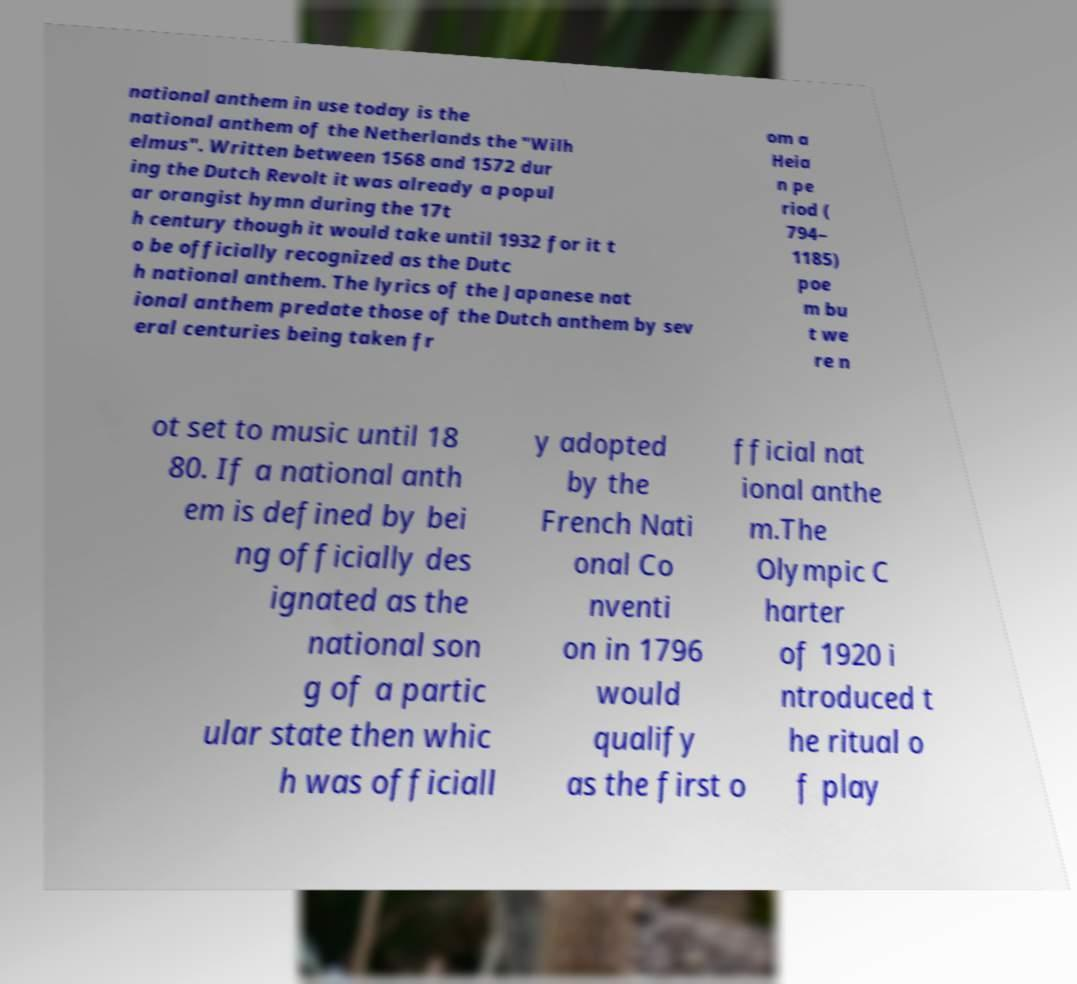What messages or text are displayed in this image? I need them in a readable, typed format. national anthem in use today is the national anthem of the Netherlands the "Wilh elmus". Written between 1568 and 1572 dur ing the Dutch Revolt it was already a popul ar orangist hymn during the 17t h century though it would take until 1932 for it t o be officially recognized as the Dutc h national anthem. The lyrics of the Japanese nat ional anthem predate those of the Dutch anthem by sev eral centuries being taken fr om a Heia n pe riod ( 794– 1185) poe m bu t we re n ot set to music until 18 80. If a national anth em is defined by bei ng officially des ignated as the national son g of a partic ular state then whic h was officiall y adopted by the French Nati onal Co nventi on in 1796 would qualify as the first o fficial nat ional anthe m.The Olympic C harter of 1920 i ntroduced t he ritual o f play 